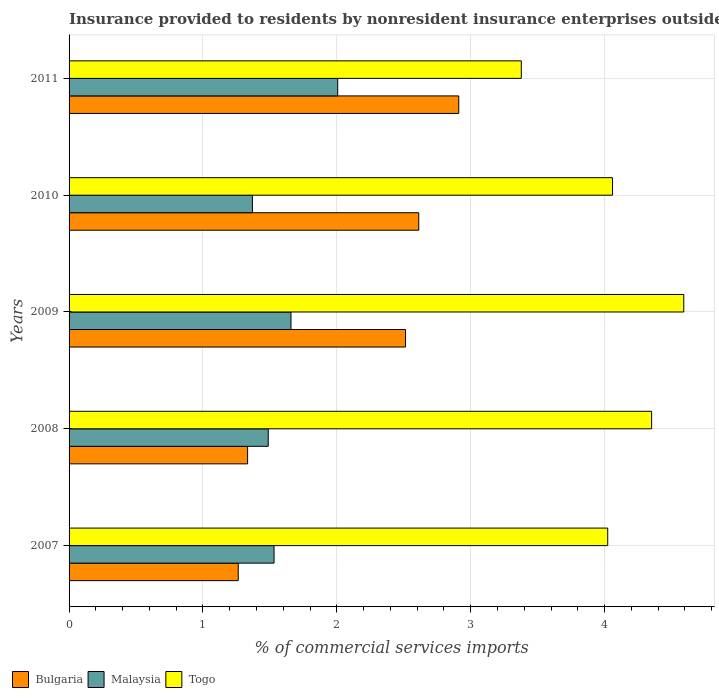How many different coloured bars are there?
Offer a very short reply. 3. How many groups of bars are there?
Your answer should be compact. 5. Are the number of bars per tick equal to the number of legend labels?
Your response must be concise. Yes. How many bars are there on the 1st tick from the top?
Your answer should be compact. 3. How many bars are there on the 4th tick from the bottom?
Provide a short and direct response. 3. What is the label of the 1st group of bars from the top?
Provide a succinct answer. 2011. In how many cases, is the number of bars for a given year not equal to the number of legend labels?
Keep it short and to the point. 0. What is the Insurance provided to residents in Togo in 2009?
Keep it short and to the point. 4.59. Across all years, what is the maximum Insurance provided to residents in Bulgaria?
Provide a succinct answer. 2.91. Across all years, what is the minimum Insurance provided to residents in Bulgaria?
Your response must be concise. 1.26. In which year was the Insurance provided to residents in Bulgaria minimum?
Make the answer very short. 2007. What is the total Insurance provided to residents in Bulgaria in the graph?
Your answer should be very brief. 10.63. What is the difference between the Insurance provided to residents in Bulgaria in 2009 and that in 2010?
Give a very brief answer. -0.1. What is the difference between the Insurance provided to residents in Togo in 2010 and the Insurance provided to residents in Malaysia in 2011?
Make the answer very short. 2.05. What is the average Insurance provided to residents in Bulgaria per year?
Offer a very short reply. 2.13. In the year 2007, what is the difference between the Insurance provided to residents in Malaysia and Insurance provided to residents in Togo?
Provide a succinct answer. -2.49. In how many years, is the Insurance provided to residents in Bulgaria greater than 4.2 %?
Your answer should be very brief. 0. What is the ratio of the Insurance provided to residents in Bulgaria in 2008 to that in 2011?
Provide a short and direct response. 0.46. What is the difference between the highest and the second highest Insurance provided to residents in Malaysia?
Your response must be concise. 0.35. What is the difference between the highest and the lowest Insurance provided to residents in Togo?
Ensure brevity in your answer.  1.21. In how many years, is the Insurance provided to residents in Malaysia greater than the average Insurance provided to residents in Malaysia taken over all years?
Your response must be concise. 2. Is the sum of the Insurance provided to residents in Malaysia in 2007 and 2009 greater than the maximum Insurance provided to residents in Bulgaria across all years?
Offer a very short reply. Yes. What does the 1st bar from the top in 2009 represents?
Keep it short and to the point. Togo. What does the 2nd bar from the bottom in 2011 represents?
Your answer should be compact. Malaysia. Is it the case that in every year, the sum of the Insurance provided to residents in Malaysia and Insurance provided to residents in Bulgaria is greater than the Insurance provided to residents in Togo?
Ensure brevity in your answer.  No. How many bars are there?
Your answer should be compact. 15. Are all the bars in the graph horizontal?
Your answer should be very brief. Yes. Does the graph contain any zero values?
Your response must be concise. No. Does the graph contain grids?
Provide a succinct answer. Yes. Where does the legend appear in the graph?
Give a very brief answer. Bottom left. How many legend labels are there?
Offer a very short reply. 3. What is the title of the graph?
Offer a very short reply. Insurance provided to residents by nonresident insurance enterprises outside a country. Does "Ukraine" appear as one of the legend labels in the graph?
Ensure brevity in your answer.  No. What is the label or title of the X-axis?
Provide a succinct answer. % of commercial services imports. What is the % of commercial services imports in Bulgaria in 2007?
Provide a succinct answer. 1.26. What is the % of commercial services imports in Malaysia in 2007?
Ensure brevity in your answer.  1.53. What is the % of commercial services imports in Togo in 2007?
Keep it short and to the point. 4.02. What is the % of commercial services imports in Bulgaria in 2008?
Provide a short and direct response. 1.33. What is the % of commercial services imports of Malaysia in 2008?
Offer a very short reply. 1.49. What is the % of commercial services imports in Togo in 2008?
Make the answer very short. 4.35. What is the % of commercial services imports in Bulgaria in 2009?
Offer a terse response. 2.51. What is the % of commercial services imports in Malaysia in 2009?
Provide a succinct answer. 1.66. What is the % of commercial services imports of Togo in 2009?
Your response must be concise. 4.59. What is the % of commercial services imports in Bulgaria in 2010?
Your answer should be very brief. 2.61. What is the % of commercial services imports in Malaysia in 2010?
Offer a terse response. 1.37. What is the % of commercial services imports in Togo in 2010?
Offer a terse response. 4.06. What is the % of commercial services imports in Bulgaria in 2011?
Offer a very short reply. 2.91. What is the % of commercial services imports of Malaysia in 2011?
Ensure brevity in your answer.  2.01. What is the % of commercial services imports in Togo in 2011?
Make the answer very short. 3.38. Across all years, what is the maximum % of commercial services imports in Bulgaria?
Make the answer very short. 2.91. Across all years, what is the maximum % of commercial services imports in Malaysia?
Ensure brevity in your answer.  2.01. Across all years, what is the maximum % of commercial services imports of Togo?
Provide a succinct answer. 4.59. Across all years, what is the minimum % of commercial services imports in Bulgaria?
Ensure brevity in your answer.  1.26. Across all years, what is the minimum % of commercial services imports in Malaysia?
Provide a short and direct response. 1.37. Across all years, what is the minimum % of commercial services imports of Togo?
Make the answer very short. 3.38. What is the total % of commercial services imports of Bulgaria in the graph?
Your response must be concise. 10.63. What is the total % of commercial services imports of Malaysia in the graph?
Provide a short and direct response. 8.05. What is the total % of commercial services imports of Togo in the graph?
Give a very brief answer. 20.4. What is the difference between the % of commercial services imports of Bulgaria in 2007 and that in 2008?
Provide a short and direct response. -0.07. What is the difference between the % of commercial services imports in Malaysia in 2007 and that in 2008?
Your answer should be compact. 0.04. What is the difference between the % of commercial services imports in Togo in 2007 and that in 2008?
Your response must be concise. -0.33. What is the difference between the % of commercial services imports in Bulgaria in 2007 and that in 2009?
Keep it short and to the point. -1.25. What is the difference between the % of commercial services imports in Malaysia in 2007 and that in 2009?
Keep it short and to the point. -0.13. What is the difference between the % of commercial services imports of Togo in 2007 and that in 2009?
Keep it short and to the point. -0.57. What is the difference between the % of commercial services imports in Bulgaria in 2007 and that in 2010?
Your answer should be very brief. -1.35. What is the difference between the % of commercial services imports of Malaysia in 2007 and that in 2010?
Ensure brevity in your answer.  0.16. What is the difference between the % of commercial services imports of Togo in 2007 and that in 2010?
Ensure brevity in your answer.  -0.04. What is the difference between the % of commercial services imports in Bulgaria in 2007 and that in 2011?
Offer a terse response. -1.65. What is the difference between the % of commercial services imports in Malaysia in 2007 and that in 2011?
Offer a very short reply. -0.48. What is the difference between the % of commercial services imports in Togo in 2007 and that in 2011?
Give a very brief answer. 0.65. What is the difference between the % of commercial services imports of Bulgaria in 2008 and that in 2009?
Give a very brief answer. -1.18. What is the difference between the % of commercial services imports in Malaysia in 2008 and that in 2009?
Provide a succinct answer. -0.17. What is the difference between the % of commercial services imports in Togo in 2008 and that in 2009?
Your answer should be very brief. -0.24. What is the difference between the % of commercial services imports of Bulgaria in 2008 and that in 2010?
Ensure brevity in your answer.  -1.28. What is the difference between the % of commercial services imports in Malaysia in 2008 and that in 2010?
Offer a very short reply. 0.12. What is the difference between the % of commercial services imports in Togo in 2008 and that in 2010?
Your response must be concise. 0.29. What is the difference between the % of commercial services imports in Bulgaria in 2008 and that in 2011?
Give a very brief answer. -1.58. What is the difference between the % of commercial services imports of Malaysia in 2008 and that in 2011?
Provide a succinct answer. -0.52. What is the difference between the % of commercial services imports in Togo in 2008 and that in 2011?
Your response must be concise. 0.97. What is the difference between the % of commercial services imports of Bulgaria in 2009 and that in 2010?
Keep it short and to the point. -0.1. What is the difference between the % of commercial services imports of Malaysia in 2009 and that in 2010?
Your answer should be compact. 0.29. What is the difference between the % of commercial services imports of Togo in 2009 and that in 2010?
Your answer should be very brief. 0.53. What is the difference between the % of commercial services imports in Bulgaria in 2009 and that in 2011?
Offer a very short reply. -0.4. What is the difference between the % of commercial services imports in Malaysia in 2009 and that in 2011?
Make the answer very short. -0.35. What is the difference between the % of commercial services imports in Togo in 2009 and that in 2011?
Ensure brevity in your answer.  1.21. What is the difference between the % of commercial services imports of Bulgaria in 2010 and that in 2011?
Your answer should be very brief. -0.3. What is the difference between the % of commercial services imports in Malaysia in 2010 and that in 2011?
Provide a short and direct response. -0.64. What is the difference between the % of commercial services imports of Togo in 2010 and that in 2011?
Your response must be concise. 0.68. What is the difference between the % of commercial services imports of Bulgaria in 2007 and the % of commercial services imports of Malaysia in 2008?
Keep it short and to the point. -0.22. What is the difference between the % of commercial services imports of Bulgaria in 2007 and the % of commercial services imports of Togo in 2008?
Provide a succinct answer. -3.09. What is the difference between the % of commercial services imports of Malaysia in 2007 and the % of commercial services imports of Togo in 2008?
Your answer should be very brief. -2.82. What is the difference between the % of commercial services imports of Bulgaria in 2007 and the % of commercial services imports of Malaysia in 2009?
Ensure brevity in your answer.  -0.39. What is the difference between the % of commercial services imports in Bulgaria in 2007 and the % of commercial services imports in Togo in 2009?
Provide a short and direct response. -3.33. What is the difference between the % of commercial services imports in Malaysia in 2007 and the % of commercial services imports in Togo in 2009?
Offer a very short reply. -3.06. What is the difference between the % of commercial services imports in Bulgaria in 2007 and the % of commercial services imports in Malaysia in 2010?
Make the answer very short. -0.11. What is the difference between the % of commercial services imports in Bulgaria in 2007 and the % of commercial services imports in Togo in 2010?
Give a very brief answer. -2.8. What is the difference between the % of commercial services imports of Malaysia in 2007 and the % of commercial services imports of Togo in 2010?
Offer a very short reply. -2.53. What is the difference between the % of commercial services imports in Bulgaria in 2007 and the % of commercial services imports in Malaysia in 2011?
Ensure brevity in your answer.  -0.74. What is the difference between the % of commercial services imports in Bulgaria in 2007 and the % of commercial services imports in Togo in 2011?
Offer a terse response. -2.11. What is the difference between the % of commercial services imports of Malaysia in 2007 and the % of commercial services imports of Togo in 2011?
Offer a very short reply. -1.85. What is the difference between the % of commercial services imports in Bulgaria in 2008 and the % of commercial services imports in Malaysia in 2009?
Ensure brevity in your answer.  -0.32. What is the difference between the % of commercial services imports of Bulgaria in 2008 and the % of commercial services imports of Togo in 2009?
Ensure brevity in your answer.  -3.26. What is the difference between the % of commercial services imports of Malaysia in 2008 and the % of commercial services imports of Togo in 2009?
Provide a succinct answer. -3.1. What is the difference between the % of commercial services imports in Bulgaria in 2008 and the % of commercial services imports in Malaysia in 2010?
Keep it short and to the point. -0.04. What is the difference between the % of commercial services imports of Bulgaria in 2008 and the % of commercial services imports of Togo in 2010?
Keep it short and to the point. -2.73. What is the difference between the % of commercial services imports in Malaysia in 2008 and the % of commercial services imports in Togo in 2010?
Provide a short and direct response. -2.57. What is the difference between the % of commercial services imports in Bulgaria in 2008 and the % of commercial services imports in Malaysia in 2011?
Your answer should be compact. -0.67. What is the difference between the % of commercial services imports in Bulgaria in 2008 and the % of commercial services imports in Togo in 2011?
Offer a very short reply. -2.04. What is the difference between the % of commercial services imports of Malaysia in 2008 and the % of commercial services imports of Togo in 2011?
Make the answer very short. -1.89. What is the difference between the % of commercial services imports of Bulgaria in 2009 and the % of commercial services imports of Malaysia in 2010?
Make the answer very short. 1.14. What is the difference between the % of commercial services imports in Bulgaria in 2009 and the % of commercial services imports in Togo in 2010?
Keep it short and to the point. -1.55. What is the difference between the % of commercial services imports in Malaysia in 2009 and the % of commercial services imports in Togo in 2010?
Provide a succinct answer. -2.4. What is the difference between the % of commercial services imports in Bulgaria in 2009 and the % of commercial services imports in Malaysia in 2011?
Your answer should be very brief. 0.51. What is the difference between the % of commercial services imports of Bulgaria in 2009 and the % of commercial services imports of Togo in 2011?
Your response must be concise. -0.86. What is the difference between the % of commercial services imports of Malaysia in 2009 and the % of commercial services imports of Togo in 2011?
Your answer should be compact. -1.72. What is the difference between the % of commercial services imports of Bulgaria in 2010 and the % of commercial services imports of Malaysia in 2011?
Make the answer very short. 0.61. What is the difference between the % of commercial services imports in Bulgaria in 2010 and the % of commercial services imports in Togo in 2011?
Keep it short and to the point. -0.77. What is the difference between the % of commercial services imports of Malaysia in 2010 and the % of commercial services imports of Togo in 2011?
Keep it short and to the point. -2.01. What is the average % of commercial services imports of Bulgaria per year?
Your answer should be compact. 2.13. What is the average % of commercial services imports of Malaysia per year?
Offer a very short reply. 1.61. What is the average % of commercial services imports of Togo per year?
Provide a succinct answer. 4.08. In the year 2007, what is the difference between the % of commercial services imports in Bulgaria and % of commercial services imports in Malaysia?
Make the answer very short. -0.27. In the year 2007, what is the difference between the % of commercial services imports in Bulgaria and % of commercial services imports in Togo?
Your response must be concise. -2.76. In the year 2007, what is the difference between the % of commercial services imports of Malaysia and % of commercial services imports of Togo?
Give a very brief answer. -2.49. In the year 2008, what is the difference between the % of commercial services imports in Bulgaria and % of commercial services imports in Malaysia?
Make the answer very short. -0.15. In the year 2008, what is the difference between the % of commercial services imports of Bulgaria and % of commercial services imports of Togo?
Ensure brevity in your answer.  -3.02. In the year 2008, what is the difference between the % of commercial services imports of Malaysia and % of commercial services imports of Togo?
Give a very brief answer. -2.86. In the year 2009, what is the difference between the % of commercial services imports of Bulgaria and % of commercial services imports of Malaysia?
Offer a very short reply. 0.86. In the year 2009, what is the difference between the % of commercial services imports in Bulgaria and % of commercial services imports in Togo?
Give a very brief answer. -2.08. In the year 2009, what is the difference between the % of commercial services imports of Malaysia and % of commercial services imports of Togo?
Keep it short and to the point. -2.93. In the year 2010, what is the difference between the % of commercial services imports of Bulgaria and % of commercial services imports of Malaysia?
Provide a short and direct response. 1.24. In the year 2010, what is the difference between the % of commercial services imports of Bulgaria and % of commercial services imports of Togo?
Keep it short and to the point. -1.45. In the year 2010, what is the difference between the % of commercial services imports of Malaysia and % of commercial services imports of Togo?
Your response must be concise. -2.69. In the year 2011, what is the difference between the % of commercial services imports in Bulgaria and % of commercial services imports in Malaysia?
Your answer should be compact. 0.9. In the year 2011, what is the difference between the % of commercial services imports of Bulgaria and % of commercial services imports of Togo?
Keep it short and to the point. -0.47. In the year 2011, what is the difference between the % of commercial services imports of Malaysia and % of commercial services imports of Togo?
Give a very brief answer. -1.37. What is the ratio of the % of commercial services imports of Bulgaria in 2007 to that in 2008?
Ensure brevity in your answer.  0.95. What is the ratio of the % of commercial services imports of Malaysia in 2007 to that in 2008?
Make the answer very short. 1.03. What is the ratio of the % of commercial services imports in Togo in 2007 to that in 2008?
Ensure brevity in your answer.  0.92. What is the ratio of the % of commercial services imports of Bulgaria in 2007 to that in 2009?
Give a very brief answer. 0.5. What is the ratio of the % of commercial services imports in Malaysia in 2007 to that in 2009?
Offer a terse response. 0.92. What is the ratio of the % of commercial services imports of Togo in 2007 to that in 2009?
Make the answer very short. 0.88. What is the ratio of the % of commercial services imports of Bulgaria in 2007 to that in 2010?
Make the answer very short. 0.48. What is the ratio of the % of commercial services imports of Malaysia in 2007 to that in 2010?
Offer a terse response. 1.12. What is the ratio of the % of commercial services imports in Bulgaria in 2007 to that in 2011?
Keep it short and to the point. 0.43. What is the ratio of the % of commercial services imports of Malaysia in 2007 to that in 2011?
Offer a terse response. 0.76. What is the ratio of the % of commercial services imports in Togo in 2007 to that in 2011?
Make the answer very short. 1.19. What is the ratio of the % of commercial services imports in Bulgaria in 2008 to that in 2009?
Provide a succinct answer. 0.53. What is the ratio of the % of commercial services imports of Malaysia in 2008 to that in 2009?
Provide a short and direct response. 0.9. What is the ratio of the % of commercial services imports of Togo in 2008 to that in 2009?
Provide a short and direct response. 0.95. What is the ratio of the % of commercial services imports in Bulgaria in 2008 to that in 2010?
Offer a terse response. 0.51. What is the ratio of the % of commercial services imports in Malaysia in 2008 to that in 2010?
Offer a very short reply. 1.09. What is the ratio of the % of commercial services imports of Togo in 2008 to that in 2010?
Ensure brevity in your answer.  1.07. What is the ratio of the % of commercial services imports of Bulgaria in 2008 to that in 2011?
Provide a succinct answer. 0.46. What is the ratio of the % of commercial services imports of Malaysia in 2008 to that in 2011?
Offer a terse response. 0.74. What is the ratio of the % of commercial services imports of Togo in 2008 to that in 2011?
Your response must be concise. 1.29. What is the ratio of the % of commercial services imports in Bulgaria in 2009 to that in 2010?
Offer a terse response. 0.96. What is the ratio of the % of commercial services imports of Malaysia in 2009 to that in 2010?
Your answer should be compact. 1.21. What is the ratio of the % of commercial services imports in Togo in 2009 to that in 2010?
Keep it short and to the point. 1.13. What is the ratio of the % of commercial services imports of Bulgaria in 2009 to that in 2011?
Offer a terse response. 0.86. What is the ratio of the % of commercial services imports of Malaysia in 2009 to that in 2011?
Offer a terse response. 0.83. What is the ratio of the % of commercial services imports in Togo in 2009 to that in 2011?
Offer a very short reply. 1.36. What is the ratio of the % of commercial services imports of Bulgaria in 2010 to that in 2011?
Offer a very short reply. 0.9. What is the ratio of the % of commercial services imports of Malaysia in 2010 to that in 2011?
Your answer should be very brief. 0.68. What is the ratio of the % of commercial services imports of Togo in 2010 to that in 2011?
Give a very brief answer. 1.2. What is the difference between the highest and the second highest % of commercial services imports in Bulgaria?
Your answer should be compact. 0.3. What is the difference between the highest and the second highest % of commercial services imports in Malaysia?
Your answer should be compact. 0.35. What is the difference between the highest and the second highest % of commercial services imports of Togo?
Offer a very short reply. 0.24. What is the difference between the highest and the lowest % of commercial services imports in Bulgaria?
Your answer should be very brief. 1.65. What is the difference between the highest and the lowest % of commercial services imports of Malaysia?
Keep it short and to the point. 0.64. What is the difference between the highest and the lowest % of commercial services imports of Togo?
Ensure brevity in your answer.  1.21. 